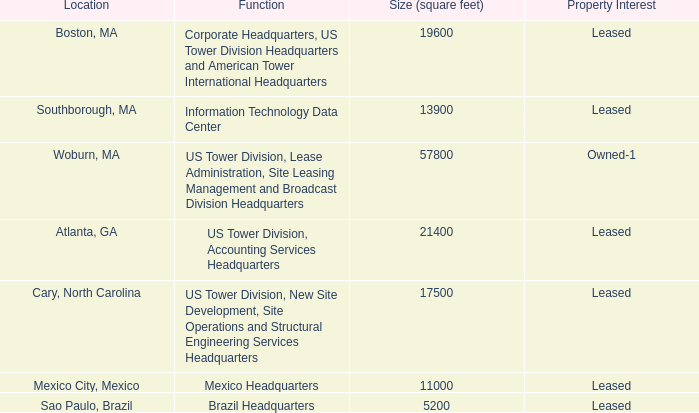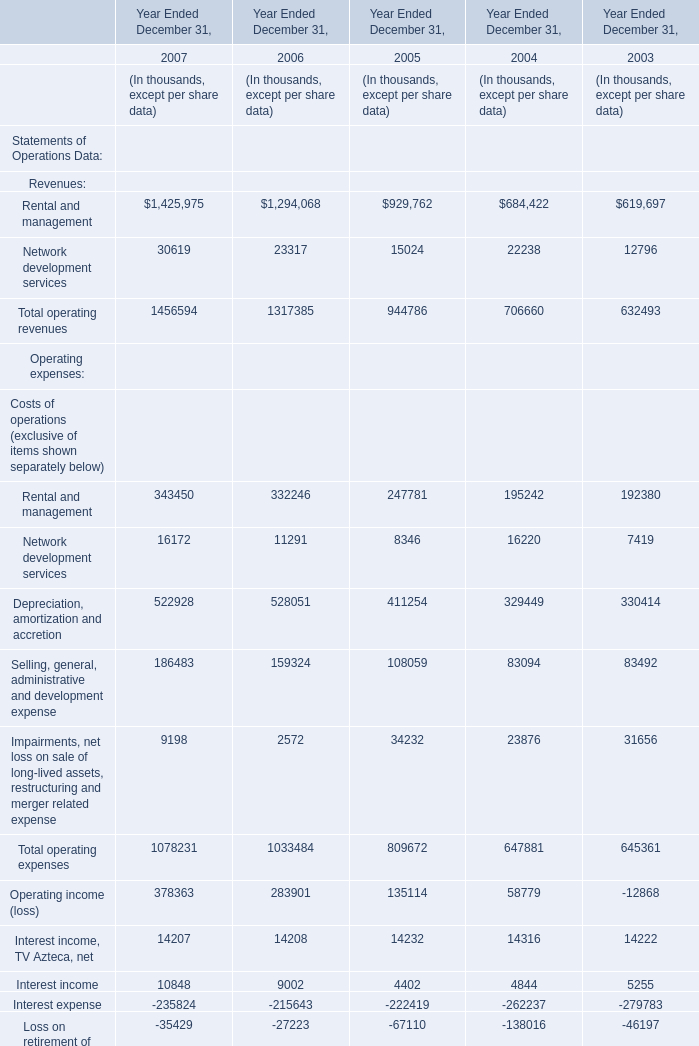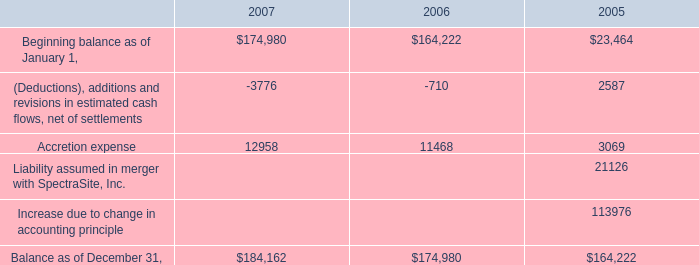what portion of the woburn property owned by the american tower corporation is subleased? 
Computations: ((163000 / 57800) / 163000)
Answer: 2e-05. 